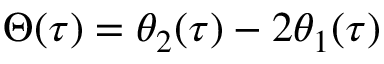<formula> <loc_0><loc_0><loc_500><loc_500>\Theta ( \tau ) = \theta _ { 2 } ( \tau ) - 2 \theta _ { 1 } ( \tau )</formula> 